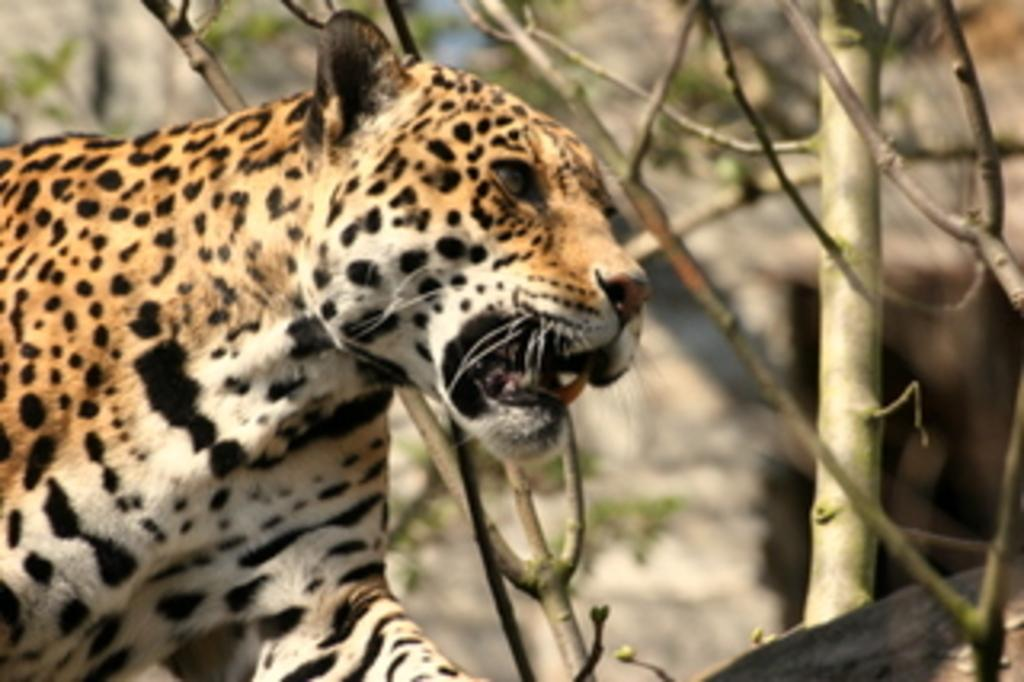What animal is on the left side of the image? There is a tiger on the left side of the image. What type of vegetation can be seen in the image? There are dried stems of trees in the image. Can you describe the background of the image? The background of the image is blurred. What type of vest is the tiger wearing in the image? The tiger is not wearing a vest in the image, as tigers do not wear clothing. 